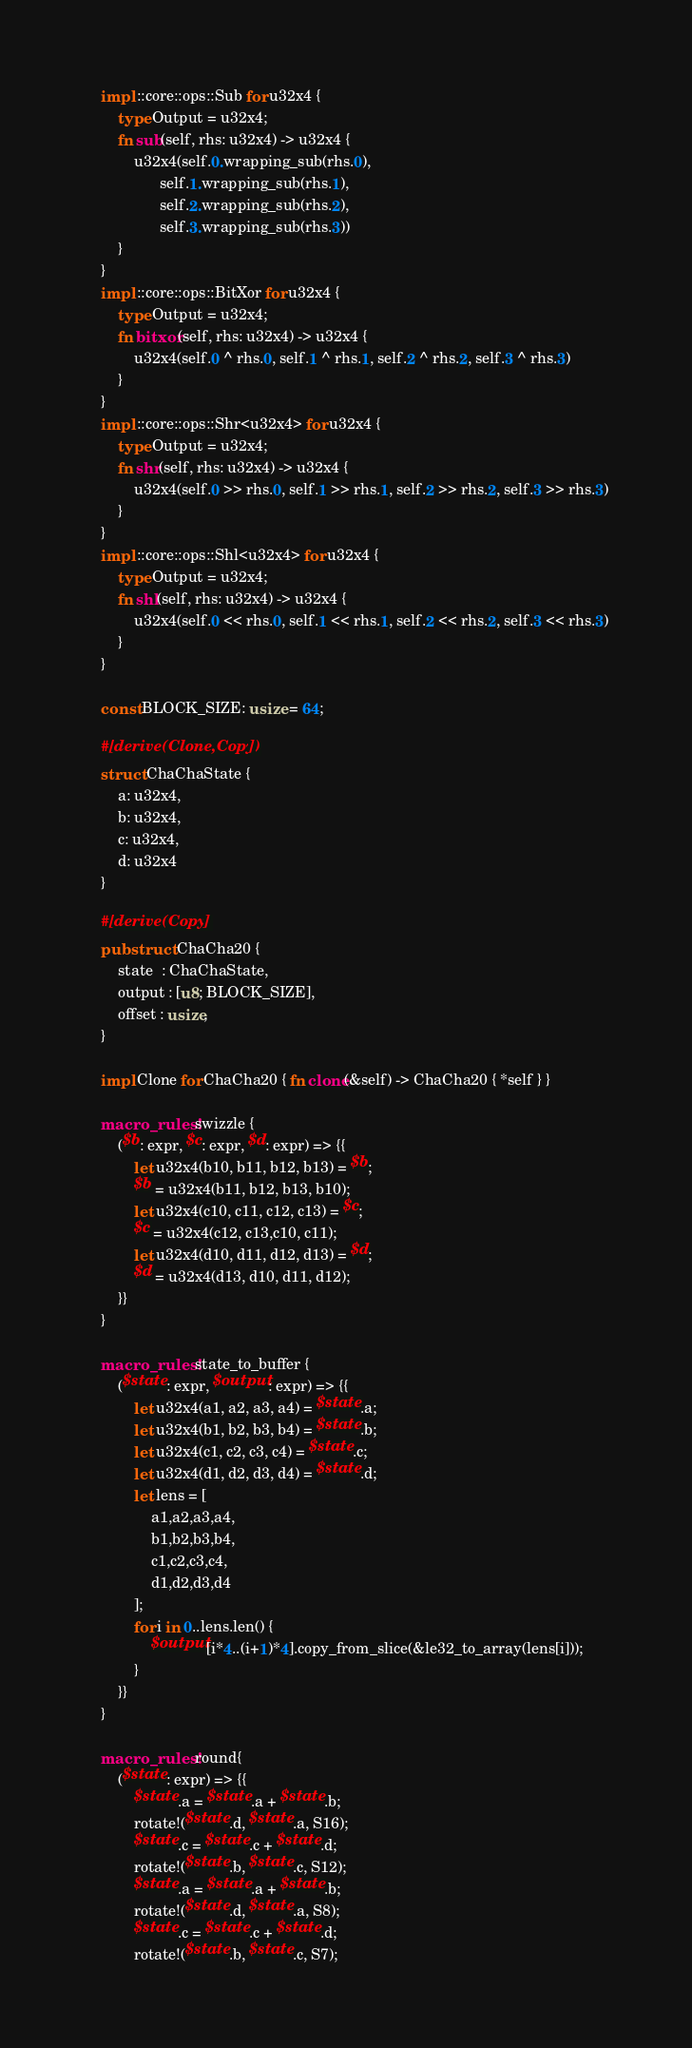<code> <loc_0><loc_0><loc_500><loc_500><_Rust_>	impl ::core::ops::Sub for u32x4 {
		type Output = u32x4;
		fn sub(self, rhs: u32x4) -> u32x4 {
			u32x4(self.0.wrapping_sub(rhs.0),
			      self.1.wrapping_sub(rhs.1),
			      self.2.wrapping_sub(rhs.2),
			      self.3.wrapping_sub(rhs.3))
		}
	}
	impl ::core::ops::BitXor for u32x4 {
		type Output = u32x4;
		fn bitxor(self, rhs: u32x4) -> u32x4 {
			u32x4(self.0 ^ rhs.0, self.1 ^ rhs.1, self.2 ^ rhs.2, self.3 ^ rhs.3)
		}
	}
	impl ::core::ops::Shr<u32x4> for u32x4 {
		type Output = u32x4;
		fn shr(self, rhs: u32x4) -> u32x4 {
			u32x4(self.0 >> rhs.0, self.1 >> rhs.1, self.2 >> rhs.2, self.3 >> rhs.3)
		}
	}
	impl ::core::ops::Shl<u32x4> for u32x4 {
		type Output = u32x4;
		fn shl(self, rhs: u32x4) -> u32x4 {
			u32x4(self.0 << rhs.0, self.1 << rhs.1, self.2 << rhs.2, self.3 << rhs.3)
		}
	}

	const BLOCK_SIZE: usize = 64;

	#[derive(Clone,Copy)]
	struct ChaChaState {
		a: u32x4,
		b: u32x4,
		c: u32x4,
		d: u32x4
	}

	#[derive(Copy)]
	pub struct ChaCha20 {
		state  : ChaChaState,
		output : [u8; BLOCK_SIZE],
		offset : usize,
	}

	impl Clone for ChaCha20 { fn clone(&self) -> ChaCha20 { *self } }

	macro_rules! swizzle {
		($b: expr, $c: expr, $d: expr) => {{
			let u32x4(b10, b11, b12, b13) = $b;
			$b = u32x4(b11, b12, b13, b10);
			let u32x4(c10, c11, c12, c13) = $c;
			$c = u32x4(c12, c13,c10, c11);
			let u32x4(d10, d11, d12, d13) = $d;
			$d = u32x4(d13, d10, d11, d12);
		}}
	}

	macro_rules! state_to_buffer {
		($state: expr, $output: expr) => {{
			let u32x4(a1, a2, a3, a4) = $state.a;
			let u32x4(b1, b2, b3, b4) = $state.b;
			let u32x4(c1, c2, c3, c4) = $state.c;
			let u32x4(d1, d2, d3, d4) = $state.d;
			let lens = [
				a1,a2,a3,a4,
				b1,b2,b3,b4,
				c1,c2,c3,c4,
				d1,d2,d3,d4
			];
			for i in 0..lens.len() {
				$output[i*4..(i+1)*4].copy_from_slice(&le32_to_array(lens[i]));
			}
		}}
	}

	macro_rules! round{
		($state: expr) => {{
			$state.a = $state.a + $state.b;
			rotate!($state.d, $state.a, S16);
			$state.c = $state.c + $state.d;
			rotate!($state.b, $state.c, S12);
			$state.a = $state.a + $state.b;
			rotate!($state.d, $state.a, S8);
			$state.c = $state.c + $state.d;
			rotate!($state.b, $state.c, S7);</code> 